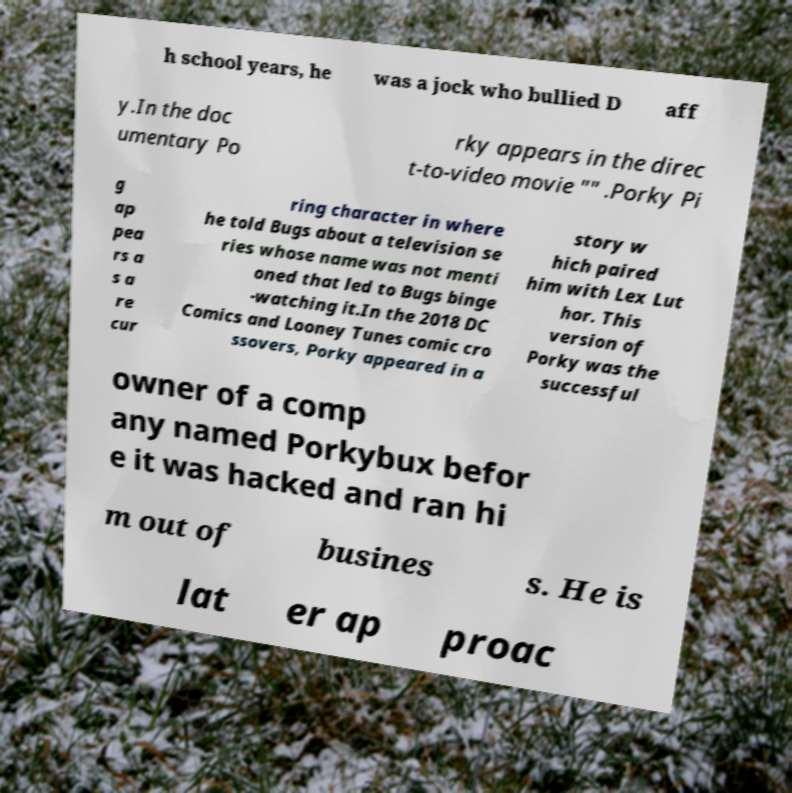For documentation purposes, I need the text within this image transcribed. Could you provide that? h school years, he was a jock who bullied D aff y.In the doc umentary Po rky appears in the direc t-to-video movie "" .Porky Pi g ap pea rs a s a re cur ring character in where he told Bugs about a television se ries whose name was not menti oned that led to Bugs binge -watching it.In the 2018 DC Comics and Looney Tunes comic cro ssovers, Porky appeared in a story w hich paired him with Lex Lut hor. This version of Porky was the successful owner of a comp any named Porkybux befor e it was hacked and ran hi m out of busines s. He is lat er ap proac 